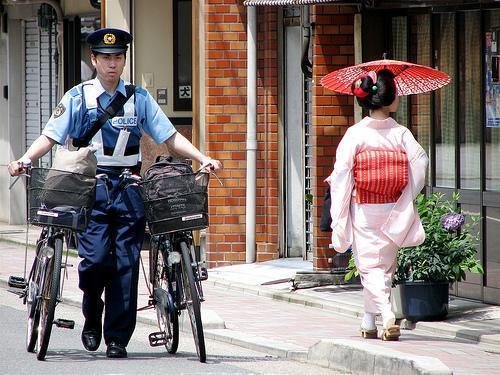How many bikes?
Give a very brief answer. 2. How many backpacks?
Give a very brief answer. 1. 